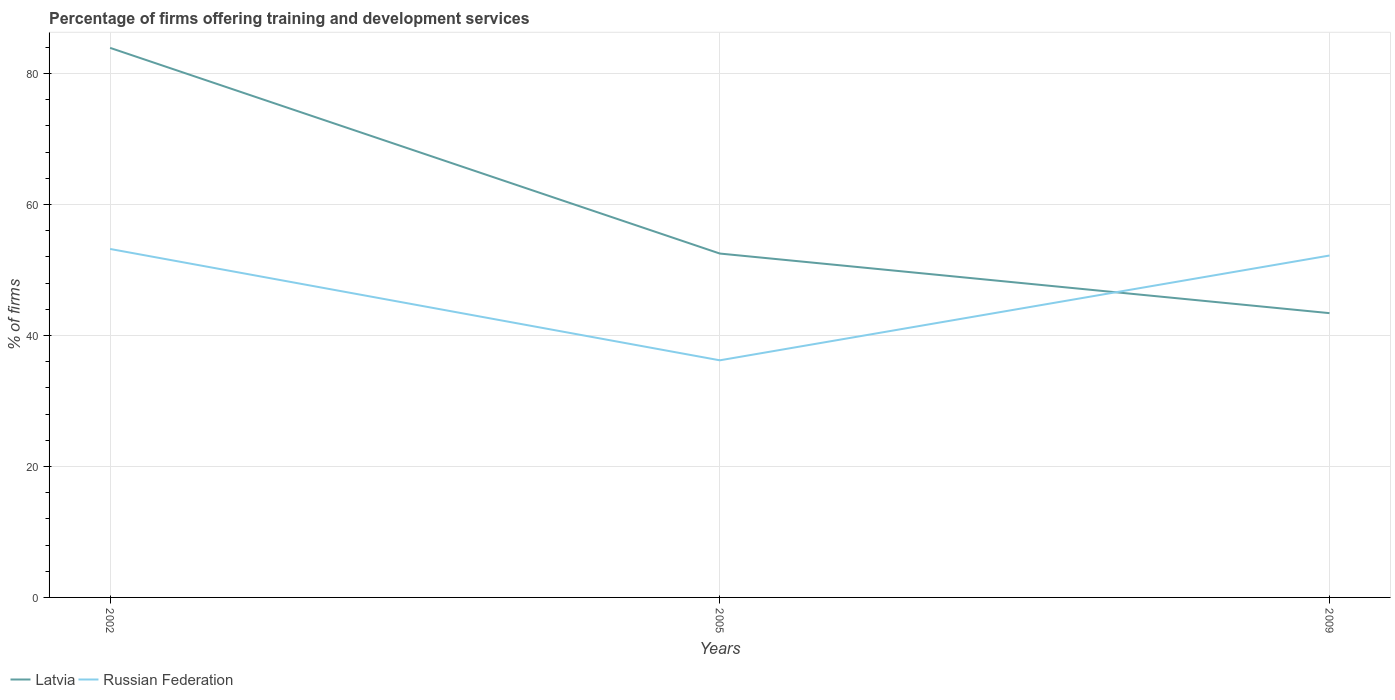How many different coloured lines are there?
Ensure brevity in your answer.  2. Does the line corresponding to Latvia intersect with the line corresponding to Russian Federation?
Keep it short and to the point. Yes. Across all years, what is the maximum percentage of firms offering training and development in Russian Federation?
Offer a very short reply. 36.2. How many years are there in the graph?
Make the answer very short. 3. Are the values on the major ticks of Y-axis written in scientific E-notation?
Provide a short and direct response. No. Does the graph contain grids?
Provide a short and direct response. Yes. Where does the legend appear in the graph?
Offer a terse response. Bottom left. What is the title of the graph?
Ensure brevity in your answer.  Percentage of firms offering training and development services. What is the label or title of the X-axis?
Give a very brief answer. Years. What is the label or title of the Y-axis?
Your answer should be compact. % of firms. What is the % of firms in Latvia in 2002?
Your answer should be compact. 83.9. What is the % of firms of Russian Federation in 2002?
Provide a succinct answer. 53.2. What is the % of firms in Latvia in 2005?
Provide a succinct answer. 52.5. What is the % of firms in Russian Federation in 2005?
Ensure brevity in your answer.  36.2. What is the % of firms in Latvia in 2009?
Your response must be concise. 43.4. What is the % of firms of Russian Federation in 2009?
Your answer should be very brief. 52.2. Across all years, what is the maximum % of firms in Latvia?
Your response must be concise. 83.9. Across all years, what is the maximum % of firms of Russian Federation?
Your response must be concise. 53.2. Across all years, what is the minimum % of firms in Latvia?
Keep it short and to the point. 43.4. Across all years, what is the minimum % of firms in Russian Federation?
Your answer should be very brief. 36.2. What is the total % of firms in Latvia in the graph?
Your answer should be compact. 179.8. What is the total % of firms in Russian Federation in the graph?
Your answer should be very brief. 141.6. What is the difference between the % of firms in Latvia in 2002 and that in 2005?
Offer a terse response. 31.4. What is the difference between the % of firms in Russian Federation in 2002 and that in 2005?
Provide a short and direct response. 17. What is the difference between the % of firms in Latvia in 2002 and that in 2009?
Your answer should be compact. 40.5. What is the difference between the % of firms in Latvia in 2005 and that in 2009?
Provide a short and direct response. 9.1. What is the difference between the % of firms in Latvia in 2002 and the % of firms in Russian Federation in 2005?
Your answer should be very brief. 47.7. What is the difference between the % of firms of Latvia in 2002 and the % of firms of Russian Federation in 2009?
Your answer should be compact. 31.7. What is the difference between the % of firms of Latvia in 2005 and the % of firms of Russian Federation in 2009?
Keep it short and to the point. 0.3. What is the average % of firms in Latvia per year?
Make the answer very short. 59.93. What is the average % of firms in Russian Federation per year?
Ensure brevity in your answer.  47.2. In the year 2002, what is the difference between the % of firms of Latvia and % of firms of Russian Federation?
Your response must be concise. 30.7. What is the ratio of the % of firms of Latvia in 2002 to that in 2005?
Provide a succinct answer. 1.6. What is the ratio of the % of firms in Russian Federation in 2002 to that in 2005?
Keep it short and to the point. 1.47. What is the ratio of the % of firms of Latvia in 2002 to that in 2009?
Keep it short and to the point. 1.93. What is the ratio of the % of firms in Russian Federation in 2002 to that in 2009?
Offer a very short reply. 1.02. What is the ratio of the % of firms in Latvia in 2005 to that in 2009?
Ensure brevity in your answer.  1.21. What is the ratio of the % of firms in Russian Federation in 2005 to that in 2009?
Make the answer very short. 0.69. What is the difference between the highest and the second highest % of firms of Latvia?
Provide a succinct answer. 31.4. What is the difference between the highest and the lowest % of firms of Latvia?
Offer a very short reply. 40.5. 